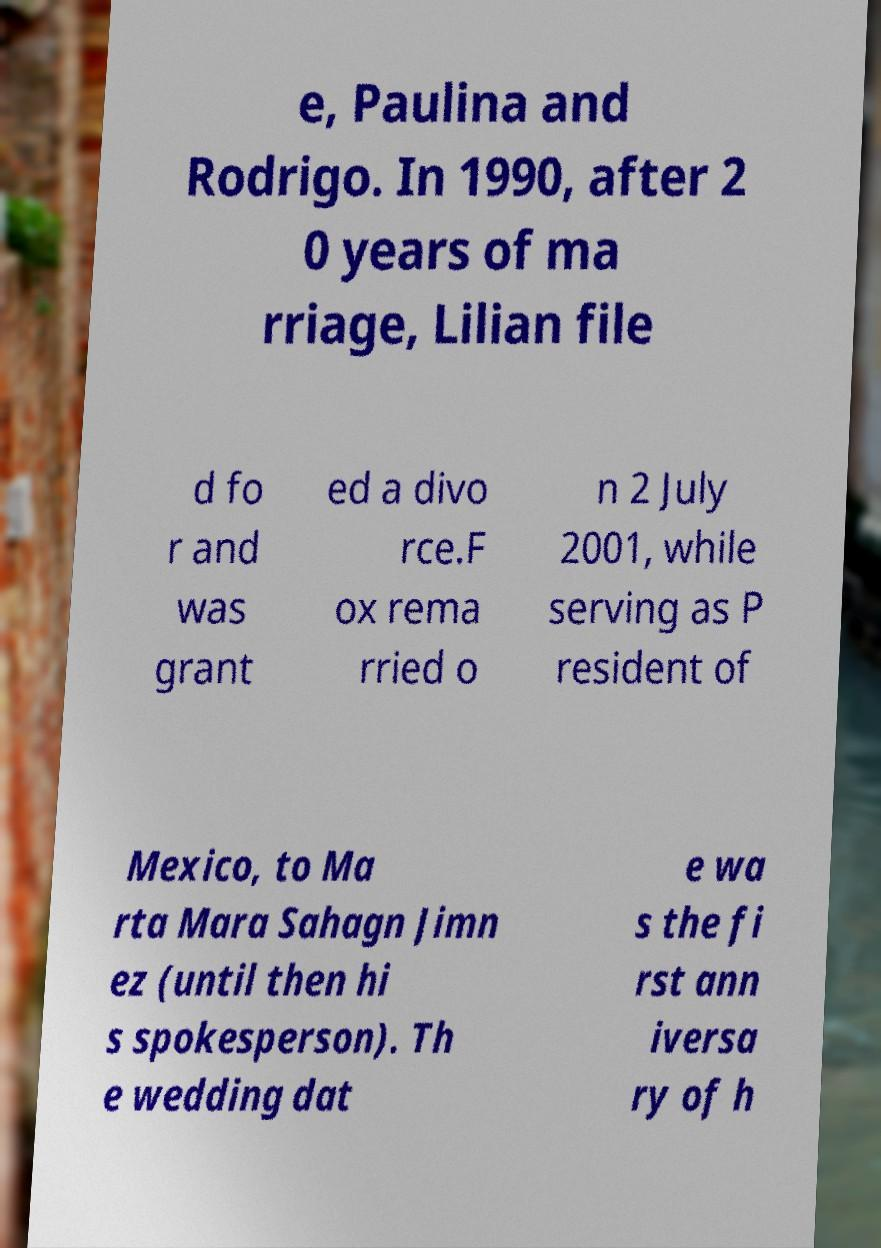Can you read and provide the text displayed in the image?This photo seems to have some interesting text. Can you extract and type it out for me? e, Paulina and Rodrigo. In 1990, after 2 0 years of ma rriage, Lilian file d fo r and was grant ed a divo rce.F ox rema rried o n 2 July 2001, while serving as P resident of Mexico, to Ma rta Mara Sahagn Jimn ez (until then hi s spokesperson). Th e wedding dat e wa s the fi rst ann iversa ry of h 